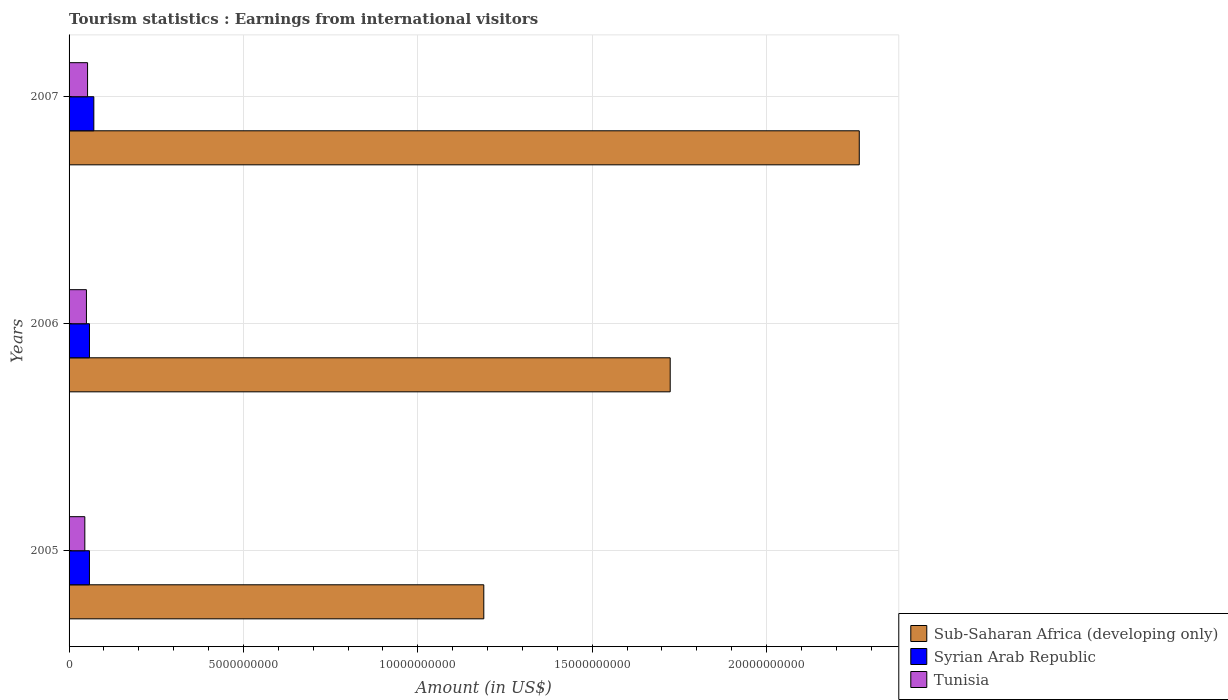How many different coloured bars are there?
Offer a very short reply. 3. How many groups of bars are there?
Your response must be concise. 3. Are the number of bars per tick equal to the number of legend labels?
Your response must be concise. Yes. Are the number of bars on each tick of the Y-axis equal?
Your response must be concise. Yes. What is the earnings from international visitors in Tunisia in 2006?
Provide a short and direct response. 4.98e+08. Across all years, what is the maximum earnings from international visitors in Syrian Arab Republic?
Make the answer very short. 7.10e+08. Across all years, what is the minimum earnings from international visitors in Sub-Saharan Africa (developing only)?
Ensure brevity in your answer.  1.19e+1. In which year was the earnings from international visitors in Tunisia maximum?
Keep it short and to the point. 2007. In which year was the earnings from international visitors in Syrian Arab Republic minimum?
Your answer should be very brief. 2005. What is the total earnings from international visitors in Tunisia in the graph?
Your response must be concise. 1.48e+09. What is the difference between the earnings from international visitors in Sub-Saharan Africa (developing only) in 2006 and that in 2007?
Provide a short and direct response. -5.42e+09. What is the difference between the earnings from international visitors in Tunisia in 2005 and the earnings from international visitors in Sub-Saharan Africa (developing only) in 2007?
Offer a terse response. -2.22e+1. What is the average earnings from international visitors in Tunisia per year?
Your response must be concise. 4.93e+08. In the year 2006, what is the difference between the earnings from international visitors in Tunisia and earnings from international visitors in Syrian Arab Republic?
Your response must be concise. -8.70e+07. In how many years, is the earnings from international visitors in Sub-Saharan Africa (developing only) greater than 18000000000 US$?
Offer a terse response. 1. What is the ratio of the earnings from international visitors in Sub-Saharan Africa (developing only) in 2005 to that in 2006?
Offer a very short reply. 0.69. Is the earnings from international visitors in Tunisia in 2005 less than that in 2007?
Make the answer very short. Yes. What is the difference between the highest and the second highest earnings from international visitors in Sub-Saharan Africa (developing only)?
Your answer should be very brief. 5.42e+09. What is the difference between the highest and the lowest earnings from international visitors in Tunisia?
Offer a very short reply. 7.80e+07. What does the 3rd bar from the top in 2006 represents?
Give a very brief answer. Sub-Saharan Africa (developing only). What does the 3rd bar from the bottom in 2005 represents?
Make the answer very short. Tunisia. Is it the case that in every year, the sum of the earnings from international visitors in Sub-Saharan Africa (developing only) and earnings from international visitors in Syrian Arab Republic is greater than the earnings from international visitors in Tunisia?
Offer a terse response. Yes. How many years are there in the graph?
Keep it short and to the point. 3. Are the values on the major ticks of X-axis written in scientific E-notation?
Your response must be concise. No. Where does the legend appear in the graph?
Provide a succinct answer. Bottom right. How many legend labels are there?
Keep it short and to the point. 3. How are the legend labels stacked?
Offer a terse response. Vertical. What is the title of the graph?
Your response must be concise. Tourism statistics : Earnings from international visitors. Does "Lower middle income" appear as one of the legend labels in the graph?
Provide a short and direct response. No. What is the label or title of the X-axis?
Keep it short and to the point. Amount (in US$). What is the Amount (in US$) of Sub-Saharan Africa (developing only) in 2005?
Provide a succinct answer. 1.19e+1. What is the Amount (in US$) in Syrian Arab Republic in 2005?
Make the answer very short. 5.84e+08. What is the Amount (in US$) of Tunisia in 2005?
Provide a succinct answer. 4.52e+08. What is the Amount (in US$) in Sub-Saharan Africa (developing only) in 2006?
Your response must be concise. 1.72e+1. What is the Amount (in US$) of Syrian Arab Republic in 2006?
Offer a very short reply. 5.85e+08. What is the Amount (in US$) in Tunisia in 2006?
Provide a succinct answer. 4.98e+08. What is the Amount (in US$) in Sub-Saharan Africa (developing only) in 2007?
Your answer should be compact. 2.27e+1. What is the Amount (in US$) in Syrian Arab Republic in 2007?
Your response must be concise. 7.10e+08. What is the Amount (in US$) of Tunisia in 2007?
Offer a terse response. 5.30e+08. Across all years, what is the maximum Amount (in US$) in Sub-Saharan Africa (developing only)?
Ensure brevity in your answer.  2.27e+1. Across all years, what is the maximum Amount (in US$) in Syrian Arab Republic?
Provide a succinct answer. 7.10e+08. Across all years, what is the maximum Amount (in US$) in Tunisia?
Provide a succinct answer. 5.30e+08. Across all years, what is the minimum Amount (in US$) in Sub-Saharan Africa (developing only)?
Your response must be concise. 1.19e+1. Across all years, what is the minimum Amount (in US$) of Syrian Arab Republic?
Offer a terse response. 5.84e+08. Across all years, what is the minimum Amount (in US$) of Tunisia?
Give a very brief answer. 4.52e+08. What is the total Amount (in US$) in Sub-Saharan Africa (developing only) in the graph?
Your response must be concise. 5.18e+1. What is the total Amount (in US$) in Syrian Arab Republic in the graph?
Provide a short and direct response. 1.88e+09. What is the total Amount (in US$) of Tunisia in the graph?
Your answer should be very brief. 1.48e+09. What is the difference between the Amount (in US$) in Sub-Saharan Africa (developing only) in 2005 and that in 2006?
Give a very brief answer. -5.34e+09. What is the difference between the Amount (in US$) of Tunisia in 2005 and that in 2006?
Offer a terse response. -4.60e+07. What is the difference between the Amount (in US$) in Sub-Saharan Africa (developing only) in 2005 and that in 2007?
Make the answer very short. -1.08e+1. What is the difference between the Amount (in US$) of Syrian Arab Republic in 2005 and that in 2007?
Your answer should be very brief. -1.26e+08. What is the difference between the Amount (in US$) of Tunisia in 2005 and that in 2007?
Give a very brief answer. -7.80e+07. What is the difference between the Amount (in US$) of Sub-Saharan Africa (developing only) in 2006 and that in 2007?
Your answer should be very brief. -5.42e+09. What is the difference between the Amount (in US$) in Syrian Arab Republic in 2006 and that in 2007?
Provide a succinct answer. -1.25e+08. What is the difference between the Amount (in US$) of Tunisia in 2006 and that in 2007?
Your answer should be very brief. -3.20e+07. What is the difference between the Amount (in US$) in Sub-Saharan Africa (developing only) in 2005 and the Amount (in US$) in Syrian Arab Republic in 2006?
Give a very brief answer. 1.13e+1. What is the difference between the Amount (in US$) in Sub-Saharan Africa (developing only) in 2005 and the Amount (in US$) in Tunisia in 2006?
Offer a very short reply. 1.14e+1. What is the difference between the Amount (in US$) of Syrian Arab Republic in 2005 and the Amount (in US$) of Tunisia in 2006?
Provide a short and direct response. 8.60e+07. What is the difference between the Amount (in US$) of Sub-Saharan Africa (developing only) in 2005 and the Amount (in US$) of Syrian Arab Republic in 2007?
Your answer should be compact. 1.12e+1. What is the difference between the Amount (in US$) in Sub-Saharan Africa (developing only) in 2005 and the Amount (in US$) in Tunisia in 2007?
Ensure brevity in your answer.  1.14e+1. What is the difference between the Amount (in US$) of Syrian Arab Republic in 2005 and the Amount (in US$) of Tunisia in 2007?
Your answer should be very brief. 5.40e+07. What is the difference between the Amount (in US$) in Sub-Saharan Africa (developing only) in 2006 and the Amount (in US$) in Syrian Arab Republic in 2007?
Provide a short and direct response. 1.65e+1. What is the difference between the Amount (in US$) in Sub-Saharan Africa (developing only) in 2006 and the Amount (in US$) in Tunisia in 2007?
Offer a terse response. 1.67e+1. What is the difference between the Amount (in US$) of Syrian Arab Republic in 2006 and the Amount (in US$) of Tunisia in 2007?
Give a very brief answer. 5.50e+07. What is the average Amount (in US$) of Sub-Saharan Africa (developing only) per year?
Your answer should be very brief. 1.73e+1. What is the average Amount (in US$) in Syrian Arab Republic per year?
Offer a terse response. 6.26e+08. What is the average Amount (in US$) in Tunisia per year?
Keep it short and to the point. 4.93e+08. In the year 2005, what is the difference between the Amount (in US$) of Sub-Saharan Africa (developing only) and Amount (in US$) of Syrian Arab Republic?
Give a very brief answer. 1.13e+1. In the year 2005, what is the difference between the Amount (in US$) of Sub-Saharan Africa (developing only) and Amount (in US$) of Tunisia?
Ensure brevity in your answer.  1.14e+1. In the year 2005, what is the difference between the Amount (in US$) in Syrian Arab Republic and Amount (in US$) in Tunisia?
Make the answer very short. 1.32e+08. In the year 2006, what is the difference between the Amount (in US$) of Sub-Saharan Africa (developing only) and Amount (in US$) of Syrian Arab Republic?
Offer a very short reply. 1.67e+1. In the year 2006, what is the difference between the Amount (in US$) in Sub-Saharan Africa (developing only) and Amount (in US$) in Tunisia?
Offer a terse response. 1.67e+1. In the year 2006, what is the difference between the Amount (in US$) in Syrian Arab Republic and Amount (in US$) in Tunisia?
Make the answer very short. 8.70e+07. In the year 2007, what is the difference between the Amount (in US$) in Sub-Saharan Africa (developing only) and Amount (in US$) in Syrian Arab Republic?
Make the answer very short. 2.19e+1. In the year 2007, what is the difference between the Amount (in US$) in Sub-Saharan Africa (developing only) and Amount (in US$) in Tunisia?
Ensure brevity in your answer.  2.21e+1. In the year 2007, what is the difference between the Amount (in US$) of Syrian Arab Republic and Amount (in US$) of Tunisia?
Make the answer very short. 1.80e+08. What is the ratio of the Amount (in US$) of Sub-Saharan Africa (developing only) in 2005 to that in 2006?
Give a very brief answer. 0.69. What is the ratio of the Amount (in US$) of Syrian Arab Republic in 2005 to that in 2006?
Make the answer very short. 1. What is the ratio of the Amount (in US$) in Tunisia in 2005 to that in 2006?
Give a very brief answer. 0.91. What is the ratio of the Amount (in US$) in Sub-Saharan Africa (developing only) in 2005 to that in 2007?
Make the answer very short. 0.52. What is the ratio of the Amount (in US$) in Syrian Arab Republic in 2005 to that in 2007?
Provide a short and direct response. 0.82. What is the ratio of the Amount (in US$) of Tunisia in 2005 to that in 2007?
Provide a short and direct response. 0.85. What is the ratio of the Amount (in US$) in Sub-Saharan Africa (developing only) in 2006 to that in 2007?
Provide a short and direct response. 0.76. What is the ratio of the Amount (in US$) in Syrian Arab Republic in 2006 to that in 2007?
Offer a very short reply. 0.82. What is the ratio of the Amount (in US$) in Tunisia in 2006 to that in 2007?
Provide a short and direct response. 0.94. What is the difference between the highest and the second highest Amount (in US$) in Sub-Saharan Africa (developing only)?
Give a very brief answer. 5.42e+09. What is the difference between the highest and the second highest Amount (in US$) of Syrian Arab Republic?
Your answer should be very brief. 1.25e+08. What is the difference between the highest and the second highest Amount (in US$) in Tunisia?
Provide a short and direct response. 3.20e+07. What is the difference between the highest and the lowest Amount (in US$) of Sub-Saharan Africa (developing only)?
Your answer should be compact. 1.08e+1. What is the difference between the highest and the lowest Amount (in US$) in Syrian Arab Republic?
Your answer should be compact. 1.26e+08. What is the difference between the highest and the lowest Amount (in US$) in Tunisia?
Offer a terse response. 7.80e+07. 